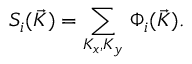<formula> <loc_0><loc_0><loc_500><loc_500>S _ { i } ( \vec { K } ) = \sum _ { K _ { x } , K _ { y } } \, \Phi _ { i } ( \vec { K } ) .</formula> 